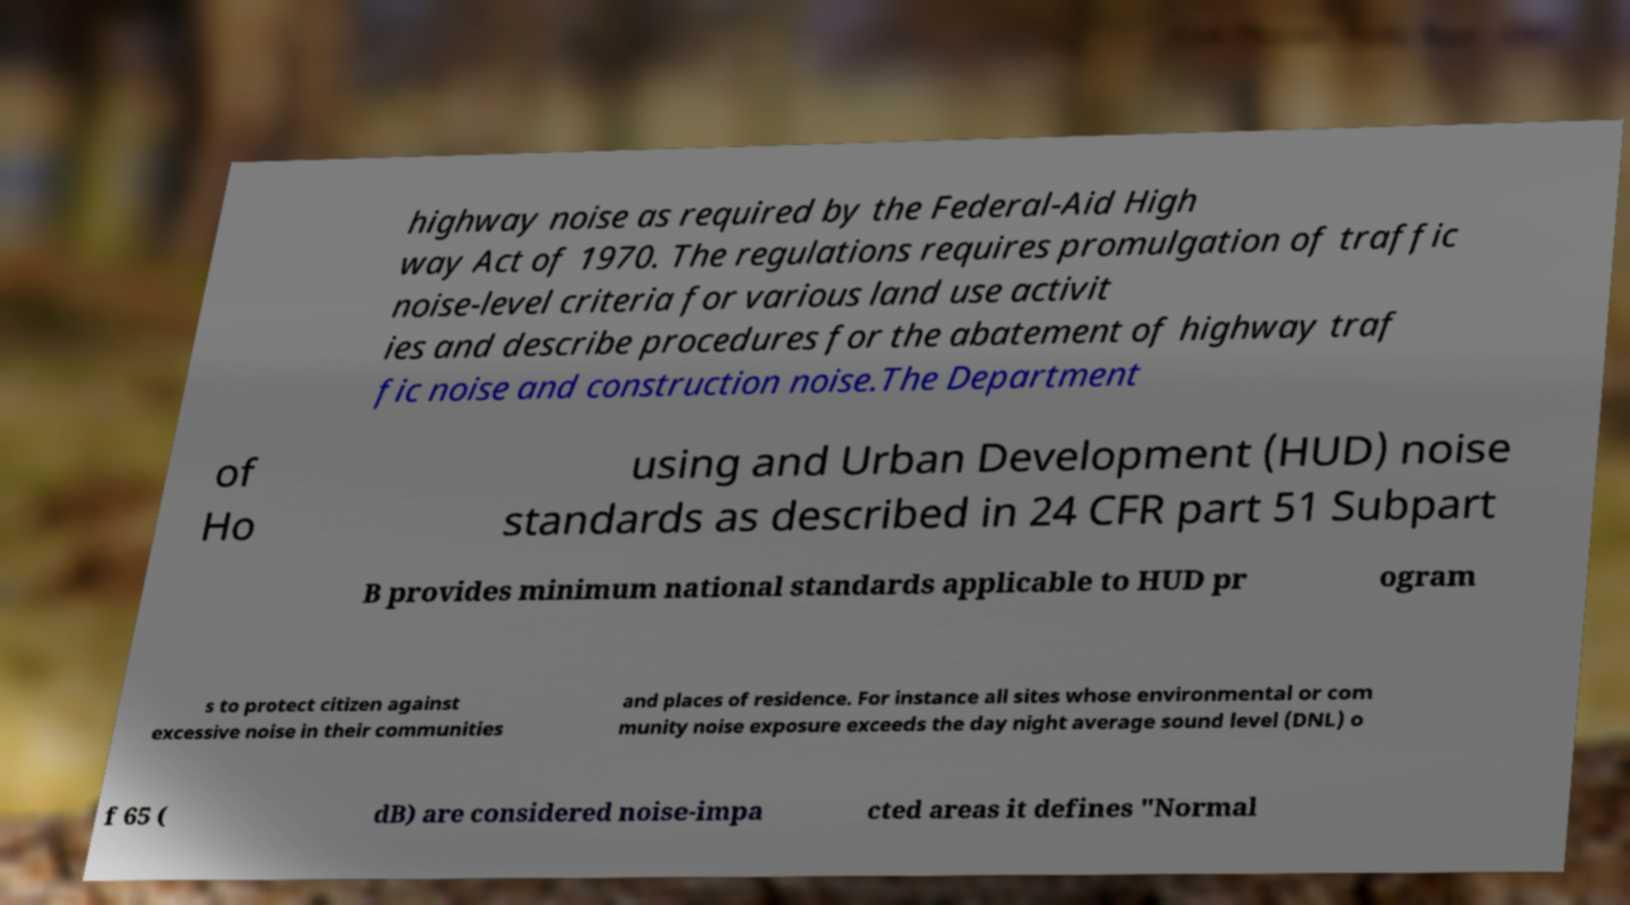Can you accurately transcribe the text from the provided image for me? highway noise as required by the Federal-Aid High way Act of 1970. The regulations requires promulgation of traffic noise-level criteria for various land use activit ies and describe procedures for the abatement of highway traf fic noise and construction noise.The Department of Ho using and Urban Development (HUD) noise standards as described in 24 CFR part 51 Subpart B provides minimum national standards applicable to HUD pr ogram s to protect citizen against excessive noise in their communities and places of residence. For instance all sites whose environmental or com munity noise exposure exceeds the day night average sound level (DNL) o f 65 ( dB) are considered noise-impa cted areas it defines "Normal 